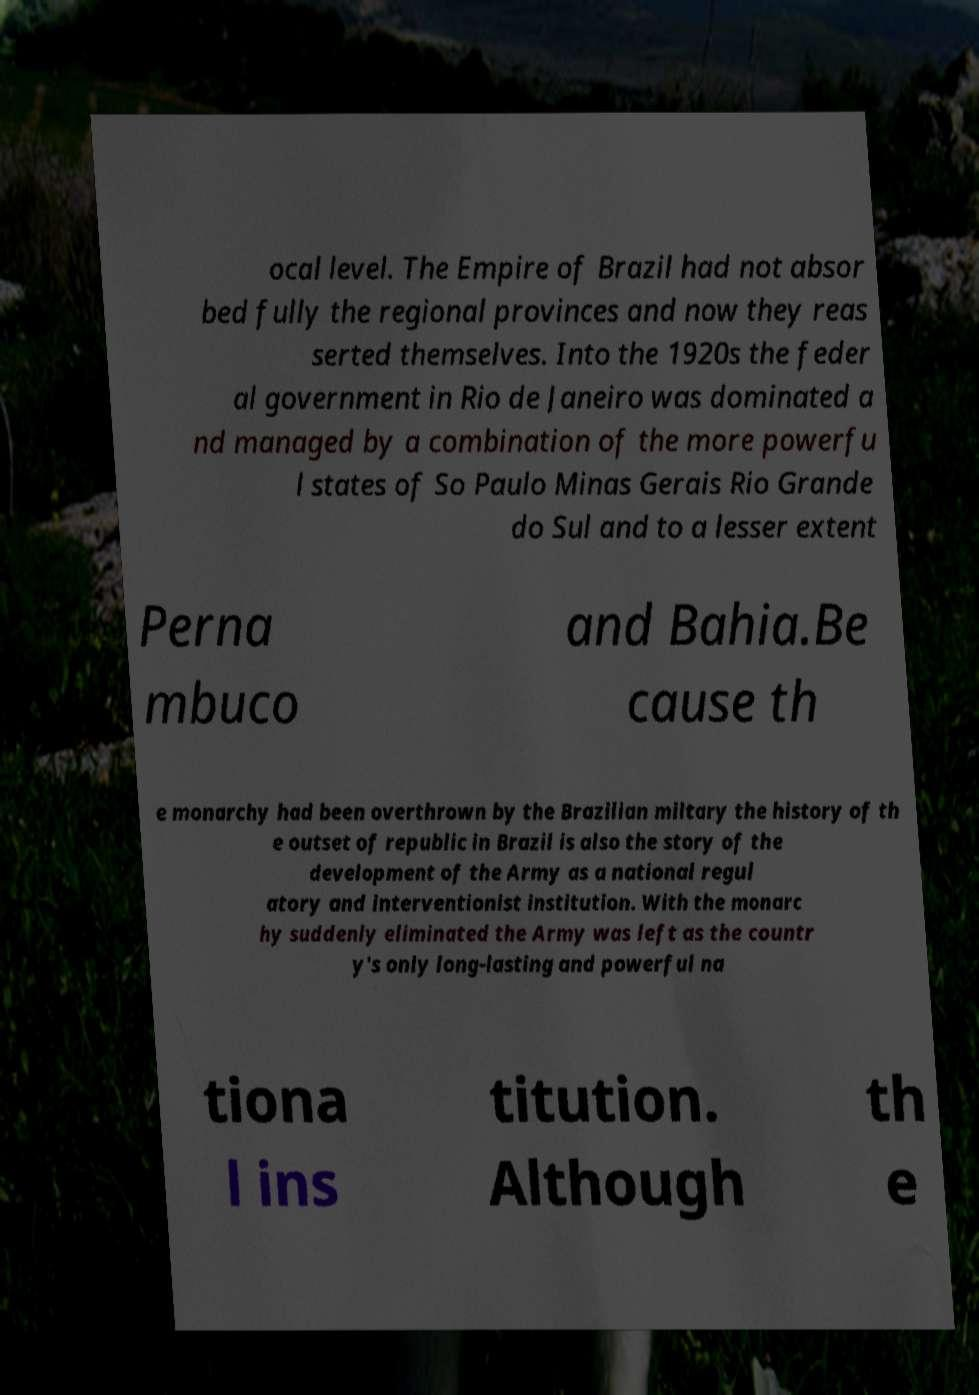Can you read and provide the text displayed in the image?This photo seems to have some interesting text. Can you extract and type it out for me? ocal level. The Empire of Brazil had not absor bed fully the regional provinces and now they reas serted themselves. Into the 1920s the feder al government in Rio de Janeiro was dominated a nd managed by a combination of the more powerfu l states of So Paulo Minas Gerais Rio Grande do Sul and to a lesser extent Perna mbuco and Bahia.Be cause th e monarchy had been overthrown by the Brazilian miltary the history of th e outset of republic in Brazil is also the story of the development of the Army as a national regul atory and interventionist institution. With the monarc hy suddenly eliminated the Army was left as the countr y's only long-lasting and powerful na tiona l ins titution. Although th e 